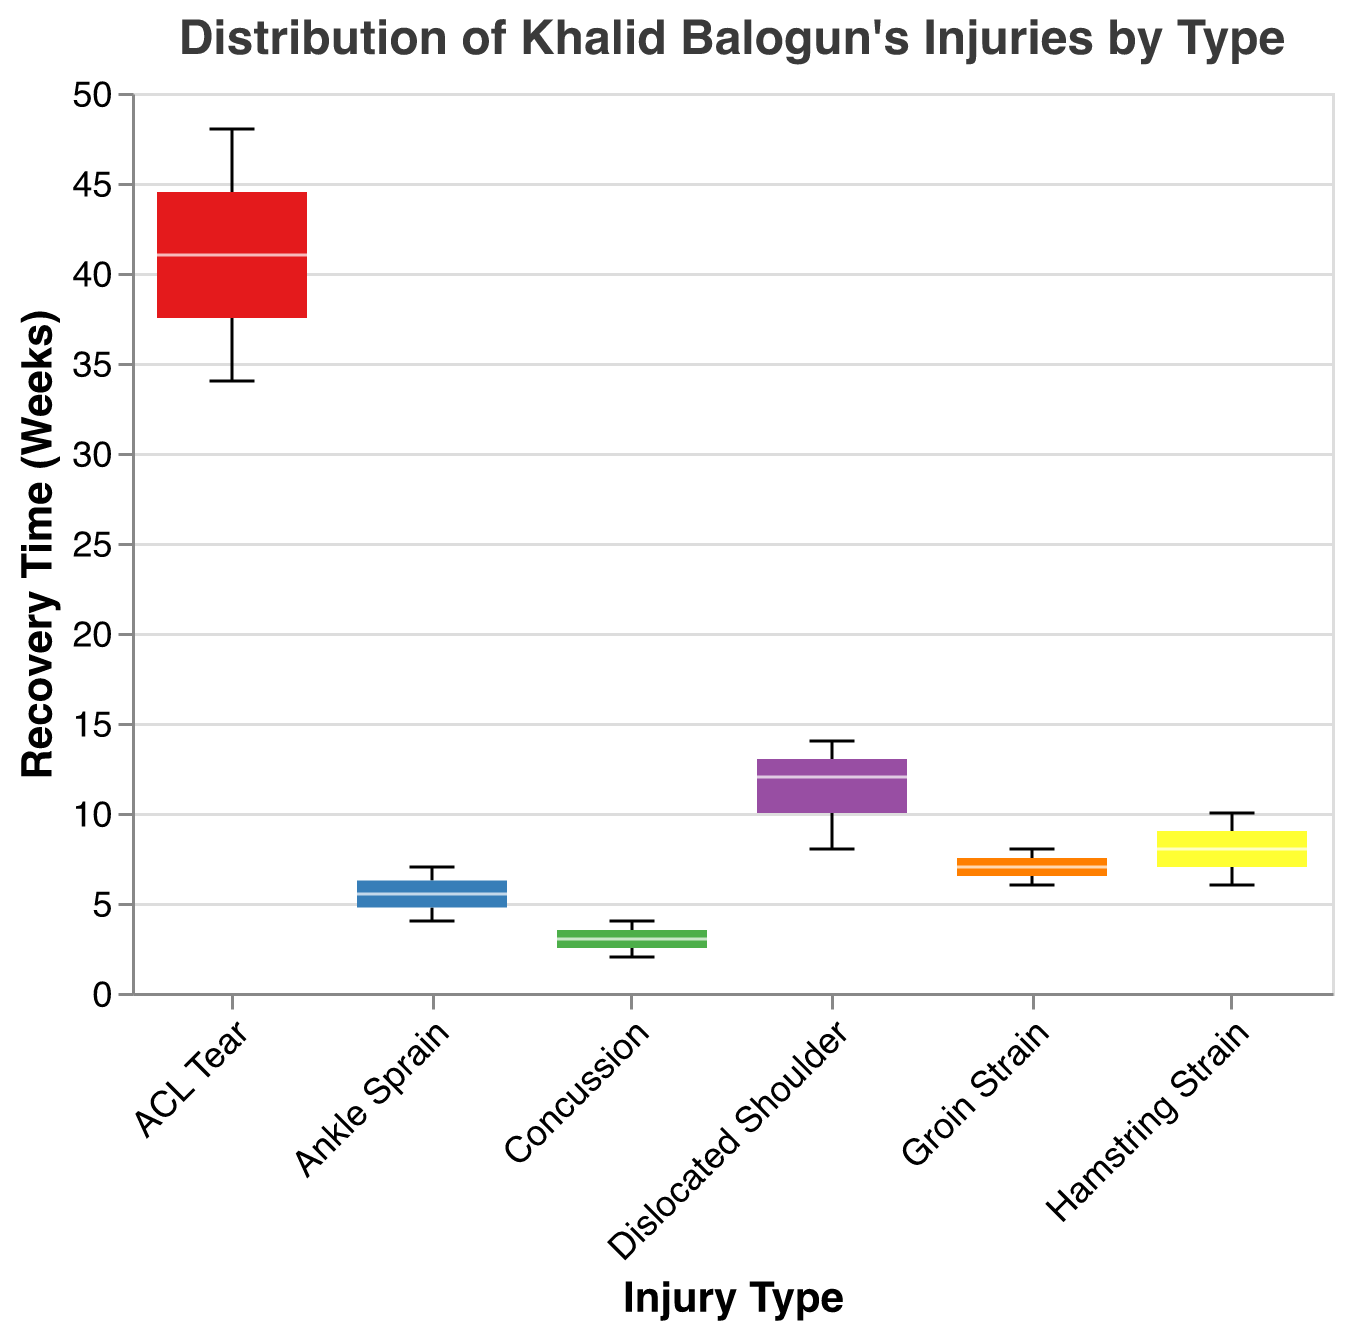What's the title of the figure? The title can be found at the top of the figure, which describes the overall content of the plot.
Answer: Distribution of Khalid Balogun's Injuries by Type Which injury type has the longest recovery time? Look at the highest point on the y-axis for each injury type. The highest value will indicate the longest recovery time.
Answer: ACL Tear What's the median recovery time for Hamstring Strain? Locate the box plot for Hamstring Strain and identify the line in the middle of the box, which represents the median.
Answer: 8 weeks How many injury types are represented in the plot? Count the distinct labels on the x-axis representing different injury types.
Answer: 6 Which injury types have recovery times with outliers? Identify the box plots with points that lie outside the whiskers; these represent outliers.
Answer: Hamstring Strain, ACL Tear, Dislocated Shoulder Among Ankle Sprain and Concussion, which has a greater median recovery time? Compare the median lines of Ankle Sprain and Concussion on the y-axis.
Answer: Ankle Sprain What's the range (difference between the maximum and minimum) of recovery times for Dislocated Shoulder? Identify the highest and lowest points within the whiskers for Dislocated Shoulder and subtract the minimum from the maximum.
Answer: 14 - 8 = 6 weeks For which injury type is the interquartile range (IQR) the smallest? Identify the injury type where the distance between the top and bottom edges of the box (quartiles) is the smallest.
Answer: Concussion Which injury type has the widest range of recovery times? Look for the injury type box plot with the longest distance between the top whisker and the bottom whisker.
Answer: ACL Tear If Khalid Balogun had an ACL Tear, how much longer (in weeks) would his recovery time be compared to a Groin Strain on average? Calculate the difference between the median recovery times of ACL Tear and Groin Strain.
Answer: ACL Tear median (41 weeks) - Groin Strain median (7 weeks) = 34 weeks 